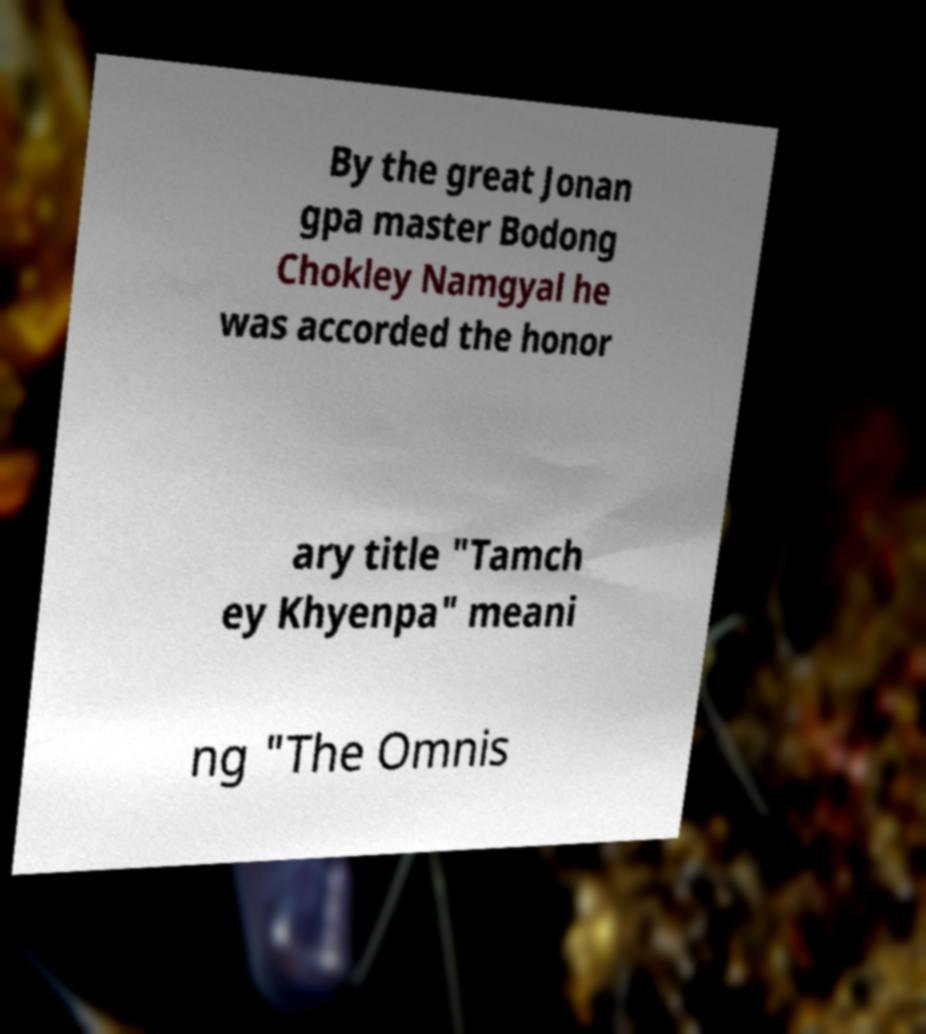Could you assist in decoding the text presented in this image and type it out clearly? By the great Jonan gpa master Bodong Chokley Namgyal he was accorded the honor ary title "Tamch ey Khyenpa" meani ng "The Omnis 